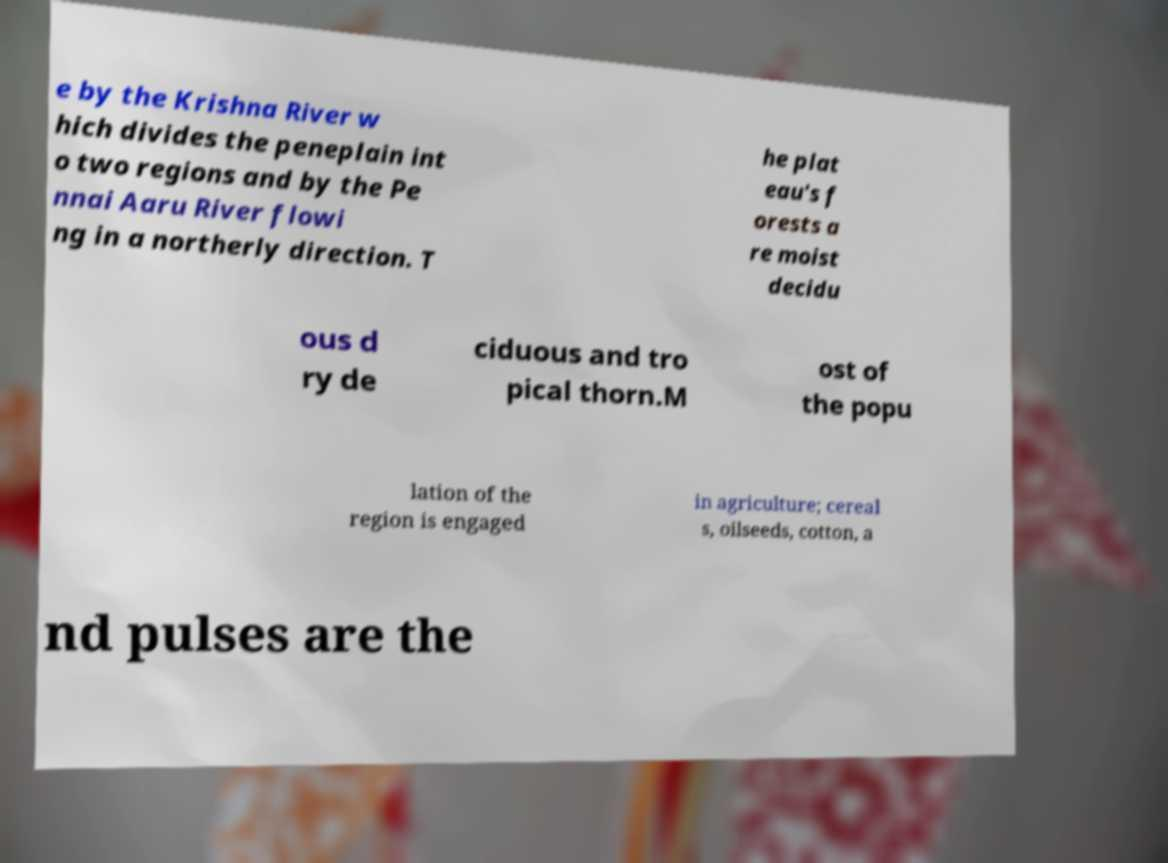I need the written content from this picture converted into text. Can you do that? e by the Krishna River w hich divides the peneplain int o two regions and by the Pe nnai Aaru River flowi ng in a northerly direction. T he plat eau's f orests a re moist decidu ous d ry de ciduous and tro pical thorn.M ost of the popu lation of the region is engaged in agriculture; cereal s, oilseeds, cotton, a nd pulses are the 